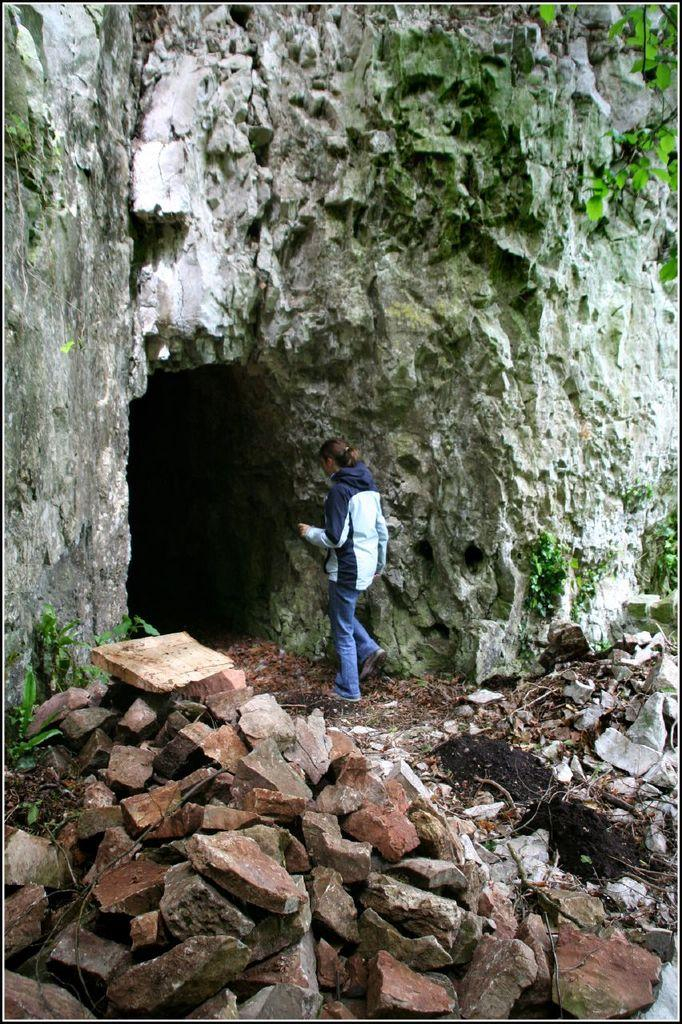Who is the main subject in the image? There is a woman in the image. What is the woman wearing? The woman is wearing a white shirt and jeans. What is the woman doing in the image? The woman is walking into a cave. What can be seen on the ground in the image? There are rocks on the ground in the front bottom of the image. What type of car can be seen parked near the cave in the image? There is no car present in the image; it only shows a woman walking into a cave with rocks on the ground. 